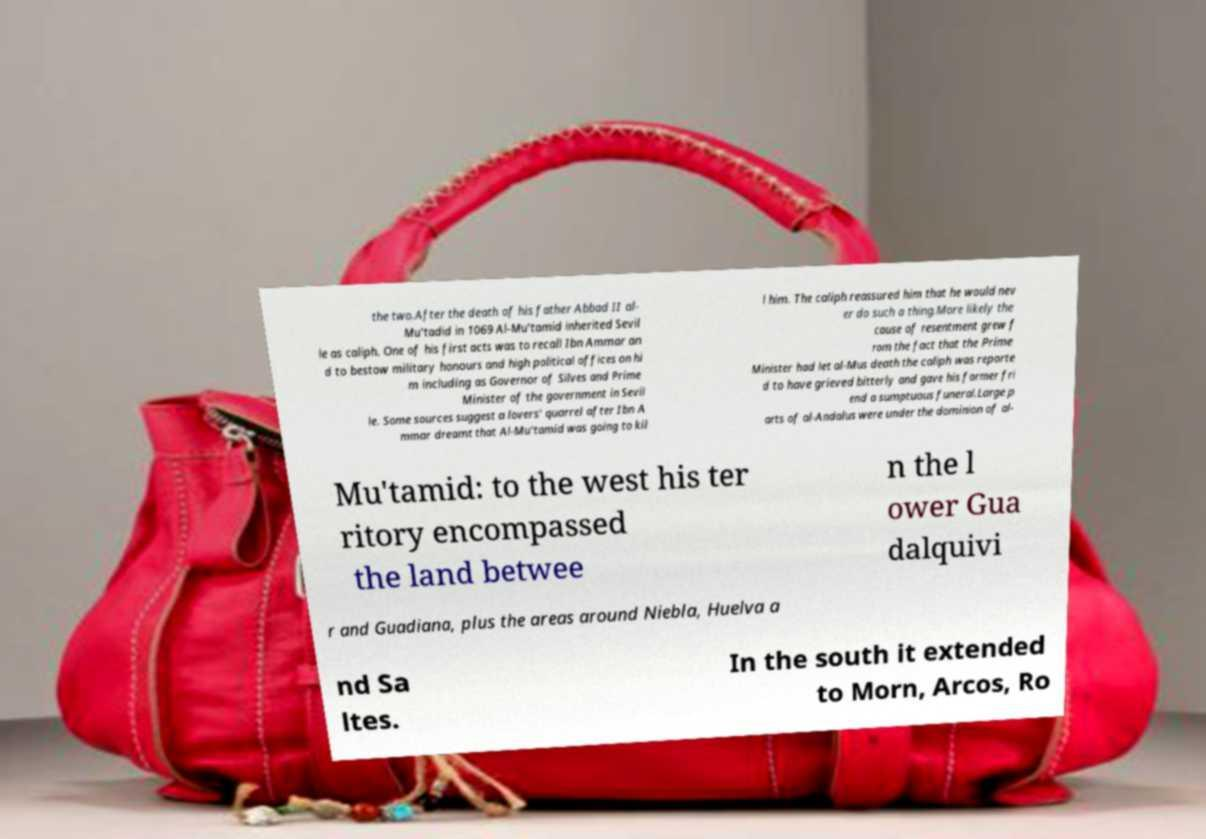Can you accurately transcribe the text from the provided image for me? the two.After the death of his father Abbad II al- Mu'tadid in 1069 Al-Mu'tamid inherited Sevil le as caliph. One of his first acts was to recall Ibn Ammar an d to bestow military honours and high political offices on hi m including as Governor of Silves and Prime Minister of the government in Sevil le. Some sources suggest a lovers' quarrel after Ibn A mmar dreamt that Al-Mu'tamid was going to kil l him. The caliph reassured him that he would nev er do such a thing.More likely the cause of resentment grew f rom the fact that the Prime Minister had let al-Mus death the caliph was reporte d to have grieved bitterly and gave his former fri end a sumptuous funeral.Large p arts of al-Andalus were under the dominion of al- Mu'tamid: to the west his ter ritory encompassed the land betwee n the l ower Gua dalquivi r and Guadiana, plus the areas around Niebla, Huelva a nd Sa ltes. In the south it extended to Morn, Arcos, Ro 